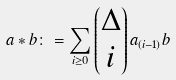Convert formula to latex. <formula><loc_0><loc_0><loc_500><loc_500>a * b \colon = \sum _ { i \geq 0 } \begin{pmatrix} \Delta \\ i \end{pmatrix} a _ { ( i - 1 ) } b</formula> 